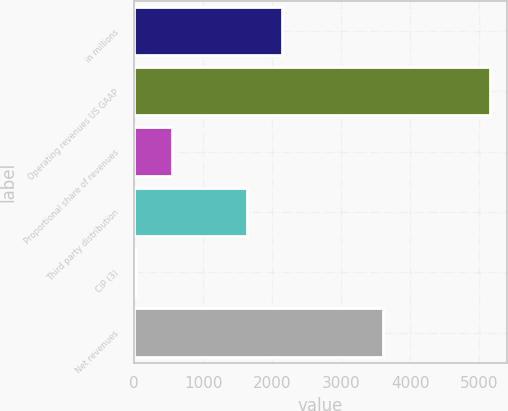Convert chart to OTSL. <chart><loc_0><loc_0><loc_500><loc_500><bar_chart><fcel>in millions<fcel>Operating revenues US GAAP<fcel>Proportional share of revenues<fcel>Third party distribution<fcel>CIP (3)<fcel>Net revenues<nl><fcel>2141.89<fcel>5147.1<fcel>546.39<fcel>1630.7<fcel>35.2<fcel>3608.3<nl></chart> 